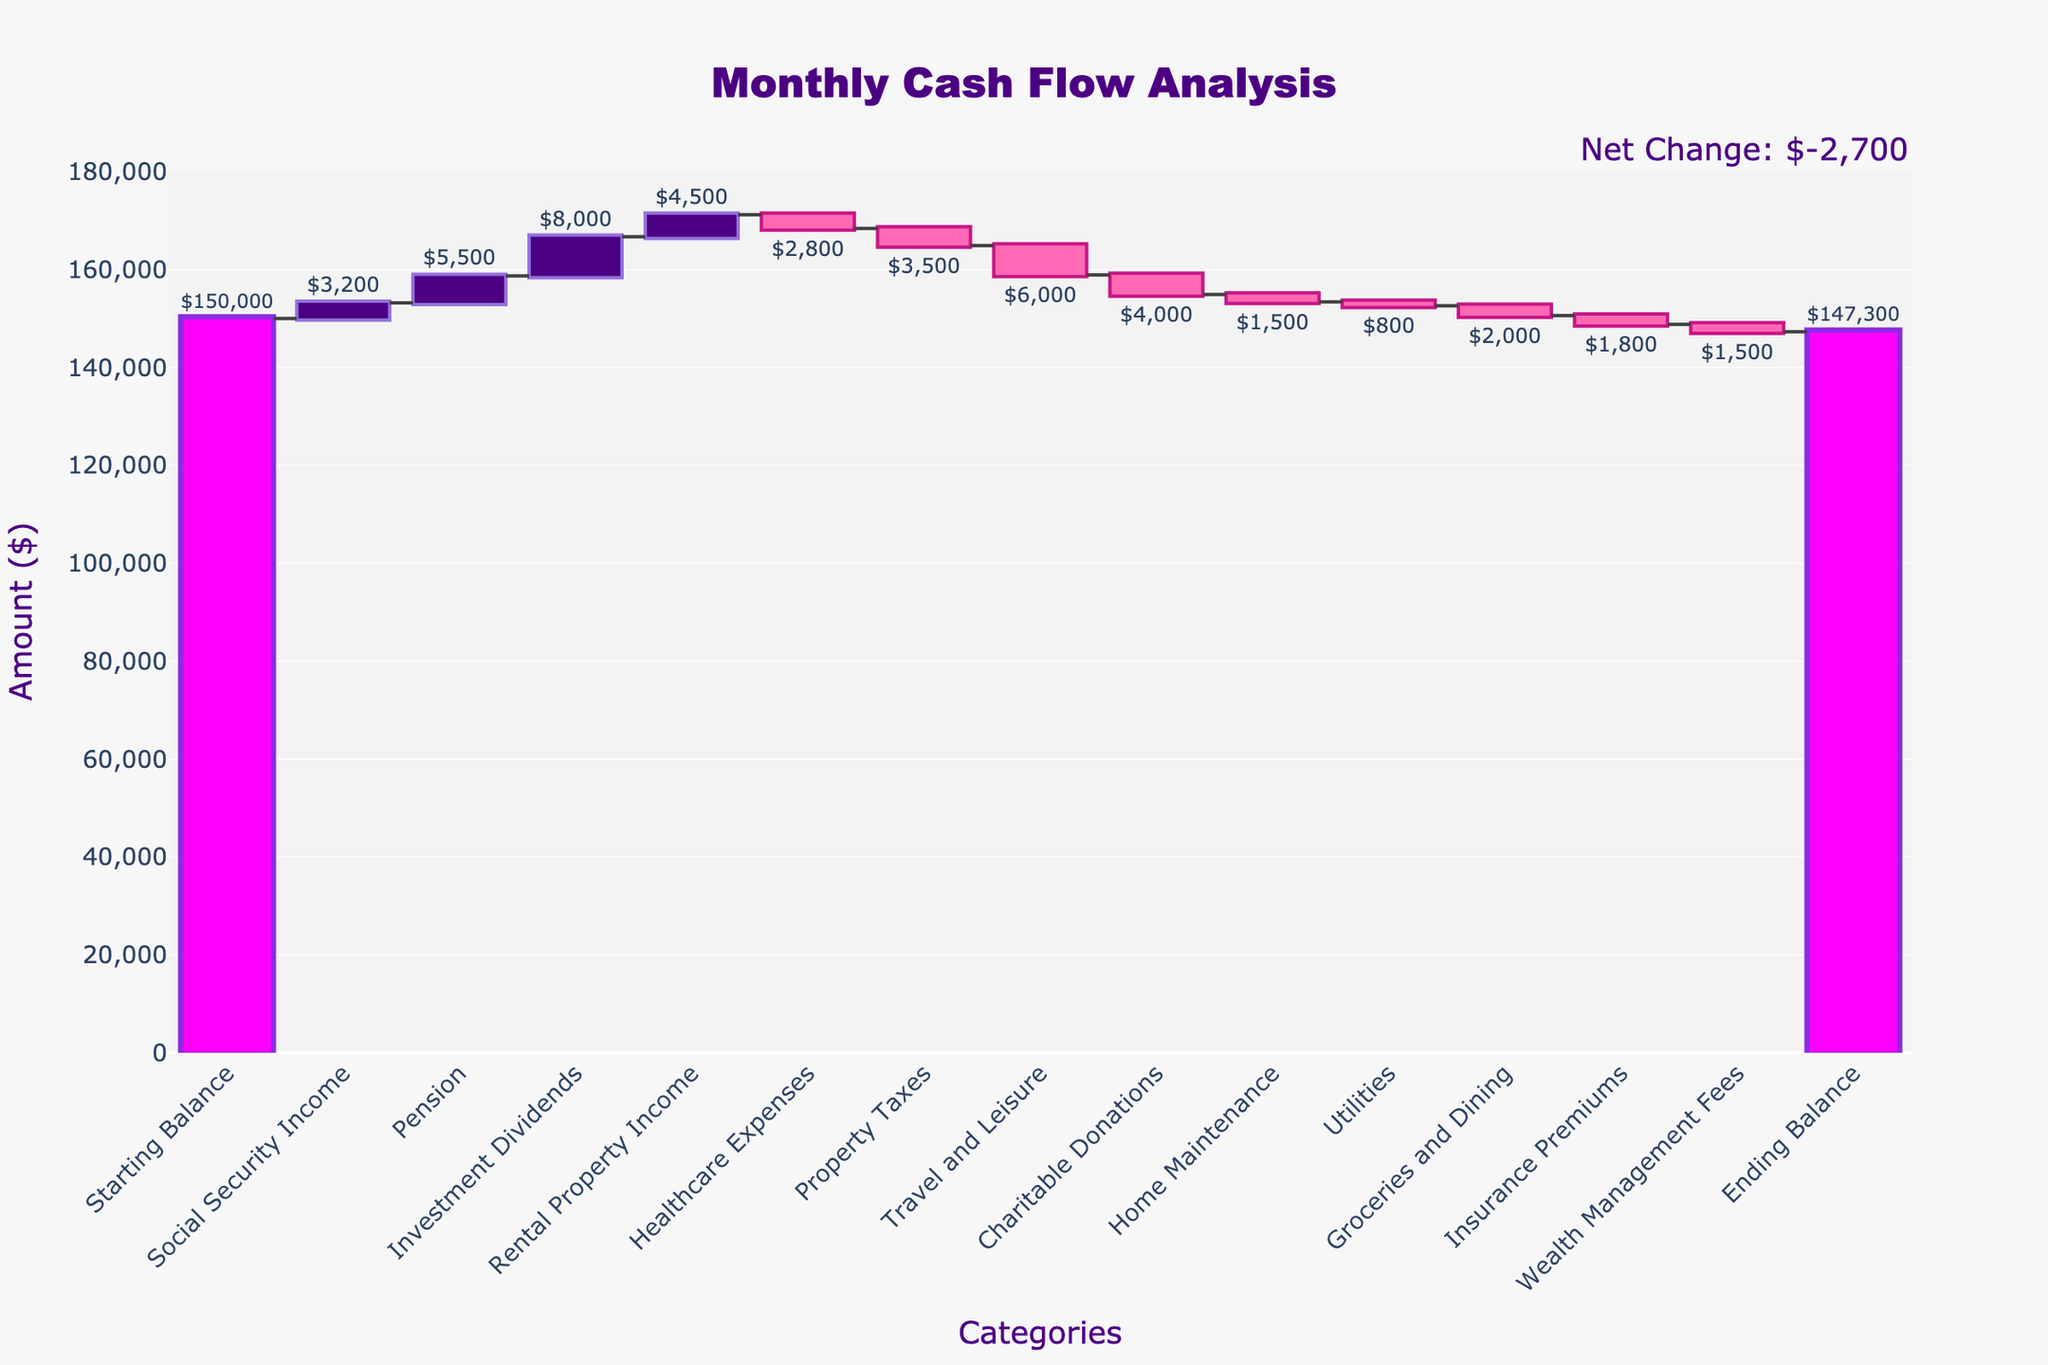How much is the starting balance? The starting balance is indicated as the first bar in the waterfall chart and labeled accordingly.
Answer: $150,000 What is the total income from Social Security, Pension, Investment Dividends, and Rental Property? Sum the values of these categories: $3200 (Social Security) + $5500 (Pension) + $8000 (Investment Dividends) + $4500 (Rental Property Income) = $21,200
Answer: $21,200 How much are the total expenses? Add up all the expense categories: $2800 (Healthcare) + $3500 (Property Taxes) + $6000 (Travel and Leisure) + $4000 (Charitable Donations) + $1500 (Home Maintenance) + $800 (Utilities) + $2000 (Groceries and Dining) + $1800 (Insurance) + $1500 (Wealth Management Fees) = $24,900
Answer: $24,900 What is the ending balance? The ending balance is indicated as the last bar in the waterfall chart and labeled accordingly.
Answer: $147,300 Which income category contributes the most to the monthly cash flow? Compare the values of Social Security Income, Pension, Investment Dividends, and Rental Property Income. The highest value is Investment Dividends at $8000.
Answer: Investment Dividends Which expense has the highest impact on the cash flow? Compare the values of all expenses. The highest value is Travel and Leisure at $6000.
Answer: Travel and Leisure What is the net change in the monthly cash flow? Subtract the starting balance from the ending balance: $147,300 - $150,000 = -$2,700
Answer: -$2,700 How does the investment dividends compare to rental property income? Compare the values of Investment Dividends ($8000) and Rental Property Income ($4500). Investment Dividends is greater.
Answer: Investment Dividends is greater What is the combined amount spent on Charitable Donations and Travel and Leisure? Add the values: $4000 (Charitable Donations) + $6000 (Travel and Leisure) = $10,000
Answer: $10,000 